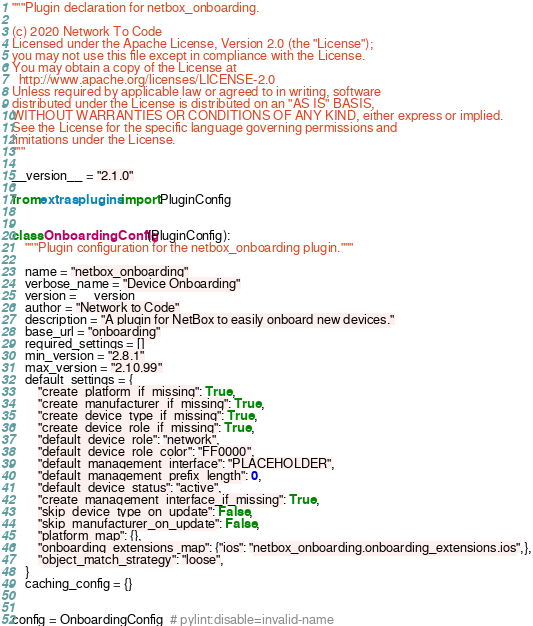Convert code to text. <code><loc_0><loc_0><loc_500><loc_500><_Python_>"""Plugin declaration for netbox_onboarding.

(c) 2020 Network To Code
Licensed under the Apache License, Version 2.0 (the "License");
you may not use this file except in compliance with the License.
You may obtain a copy of the License at
  http://www.apache.org/licenses/LICENSE-2.0
Unless required by applicable law or agreed to in writing, software
distributed under the License is distributed on an "AS IS" BASIS,
WITHOUT WARRANTIES OR CONDITIONS OF ANY KIND, either express or implied.
See the License for the specific language governing permissions and
limitations under the License.
"""

__version__ = "2.1.0"

from extras.plugins import PluginConfig


class OnboardingConfig(PluginConfig):
    """Plugin configuration for the netbox_onboarding plugin."""

    name = "netbox_onboarding"
    verbose_name = "Device Onboarding"
    version = __version__
    author = "Network to Code"
    description = "A plugin for NetBox to easily onboard new devices."
    base_url = "onboarding"
    required_settings = []
    min_version = "2.8.1"
    max_version = "2.10.99"
    default_settings = {
        "create_platform_if_missing": True,
        "create_manufacturer_if_missing": True,
        "create_device_type_if_missing": True,
        "create_device_role_if_missing": True,
        "default_device_role": "network",
        "default_device_role_color": "FF0000",
        "default_management_interface": "PLACEHOLDER",
        "default_management_prefix_length": 0,
        "default_device_status": "active",
        "create_management_interface_if_missing": True,
        "skip_device_type_on_update": False,
        "skip_manufacturer_on_update": False,
        "platform_map": {},
        "onboarding_extensions_map": {"ios": "netbox_onboarding.onboarding_extensions.ios",},
        "object_match_strategy": "loose",
    }
    caching_config = {}


config = OnboardingConfig  # pylint:disable=invalid-name
</code> 